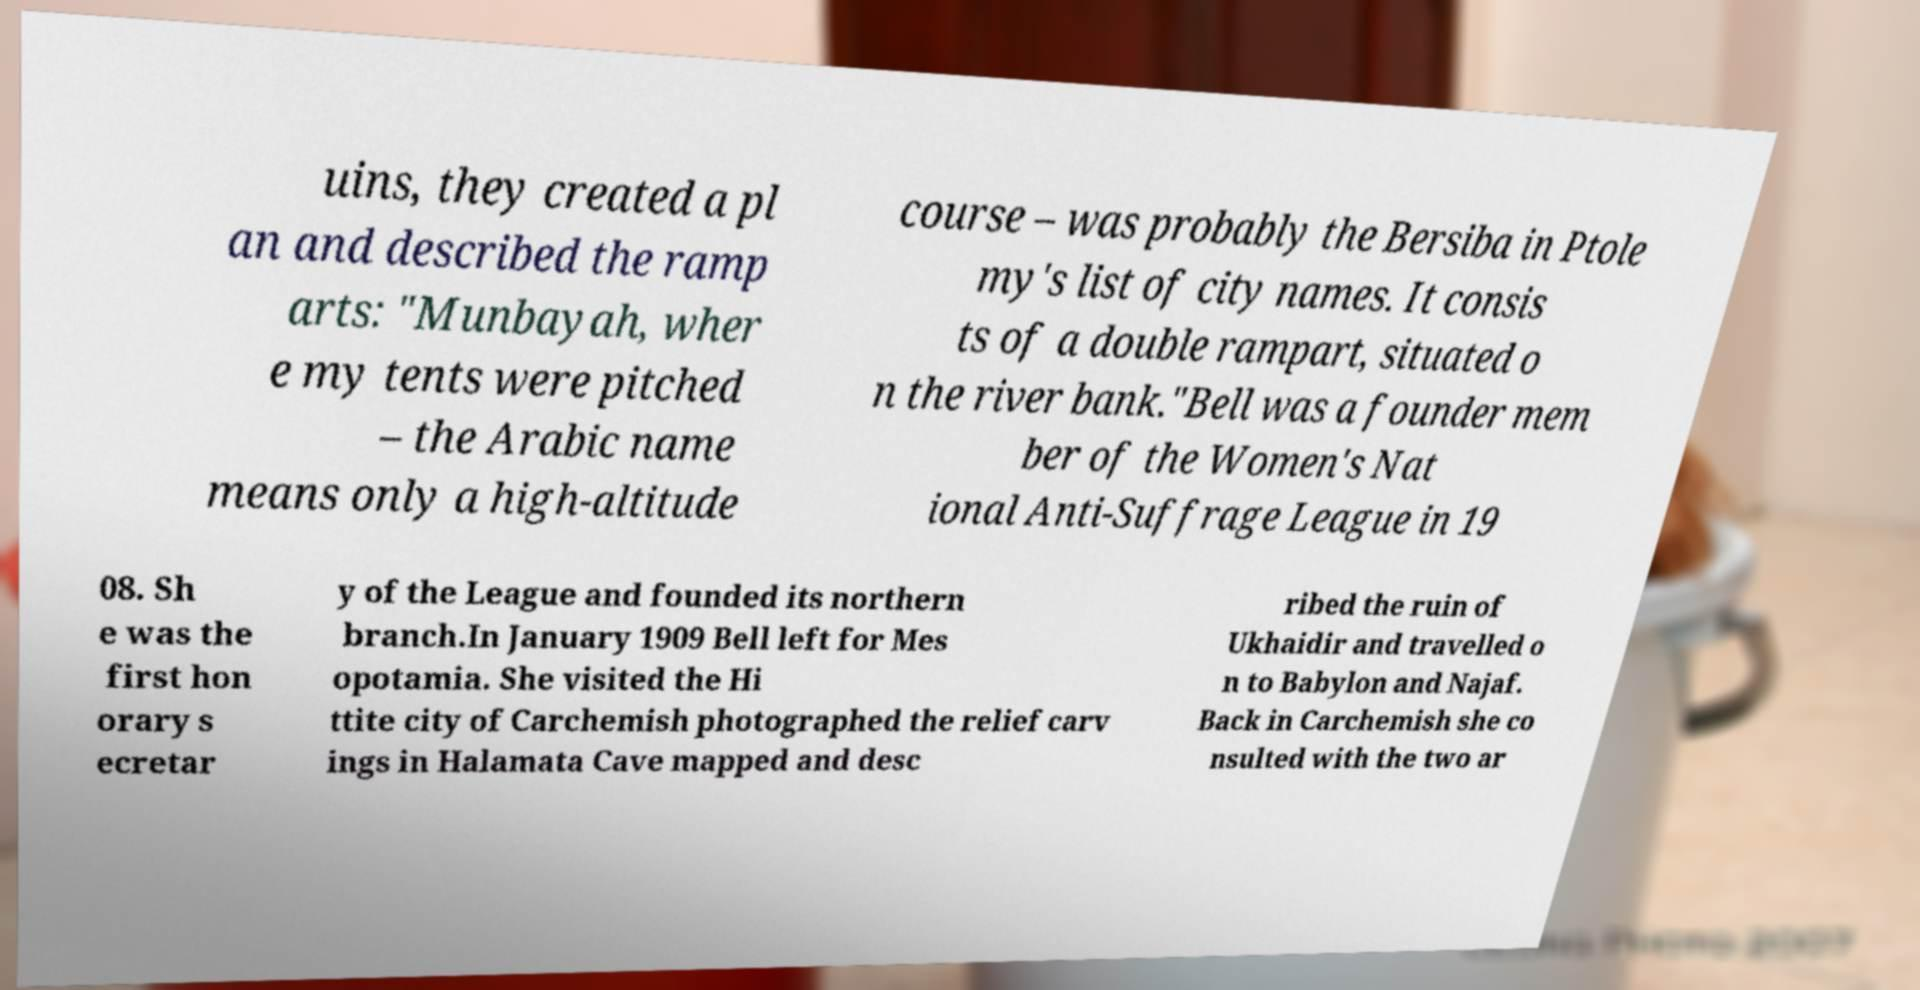Can you read and provide the text displayed in the image?This photo seems to have some interesting text. Can you extract and type it out for me? uins, they created a pl an and described the ramp arts: "Munbayah, wher e my tents were pitched – the Arabic name means only a high-altitude course – was probably the Bersiba in Ptole my's list of city names. It consis ts of a double rampart, situated o n the river bank."Bell was a founder mem ber of the Women's Nat ional Anti-Suffrage League in 19 08. Sh e was the first hon orary s ecretar y of the League and founded its northern branch.In January 1909 Bell left for Mes opotamia. She visited the Hi ttite city of Carchemish photographed the relief carv ings in Halamata Cave mapped and desc ribed the ruin of Ukhaidir and travelled o n to Babylon and Najaf. Back in Carchemish she co nsulted with the two ar 